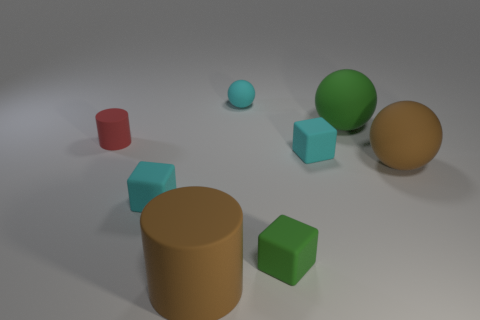Subtract all big brown balls. How many balls are left? 2 Add 2 large cyan rubber cubes. How many objects exist? 10 Subtract all cyan balls. How many balls are left? 2 Subtract all cubes. How many objects are left? 5 Add 3 red matte cylinders. How many red matte cylinders exist? 4 Subtract 1 brown cylinders. How many objects are left? 7 Subtract 1 balls. How many balls are left? 2 Subtract all blue cubes. Subtract all green cylinders. How many cubes are left? 3 Subtract all cyan cylinders. How many cyan spheres are left? 1 Subtract all cyan matte objects. Subtract all small yellow metal things. How many objects are left? 5 